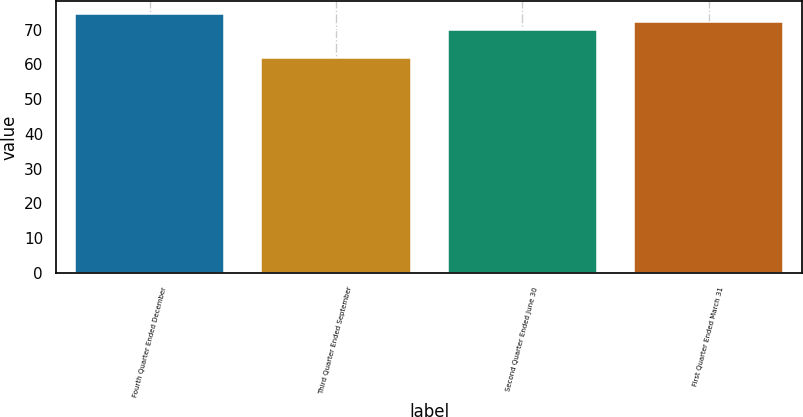<chart> <loc_0><loc_0><loc_500><loc_500><bar_chart><fcel>Fourth Quarter Ended December<fcel>Third Quarter Ended September<fcel>Second Quarter Ended June 30<fcel>First Quarter Ended March 31<nl><fcel>74.38<fcel>61.9<fcel>69.94<fcel>72.06<nl></chart> 